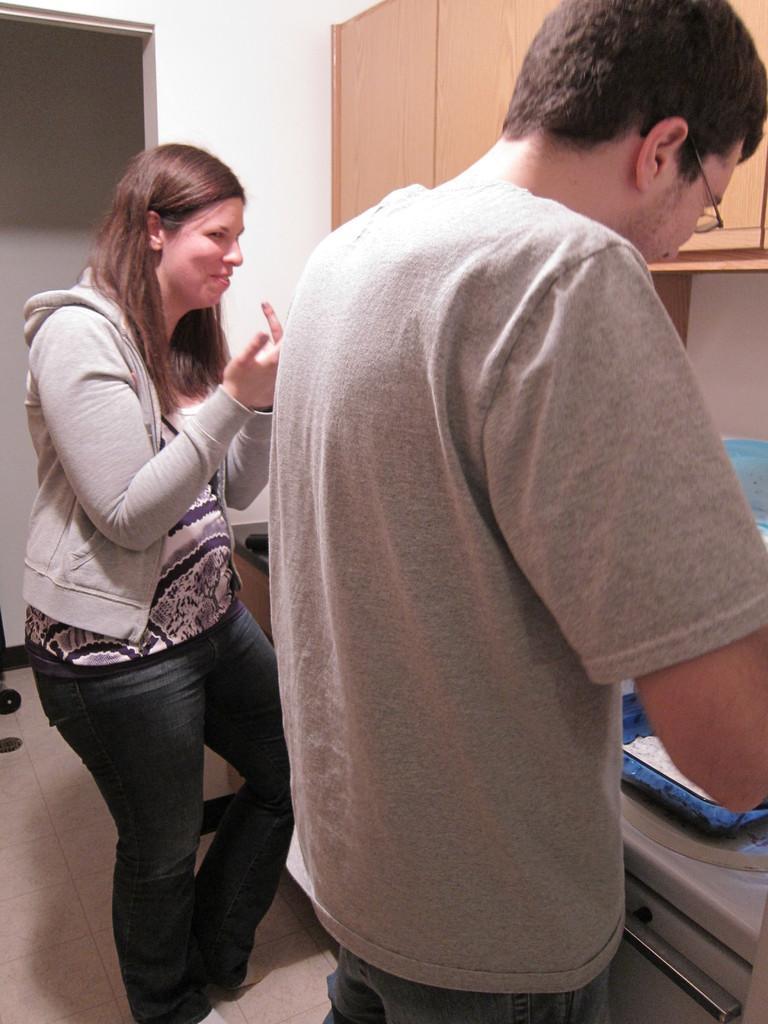How would you summarize this image in a sentence or two? In this image I can see there are two persons visible in front of table , at the top there is cupboard and the wall visible. 